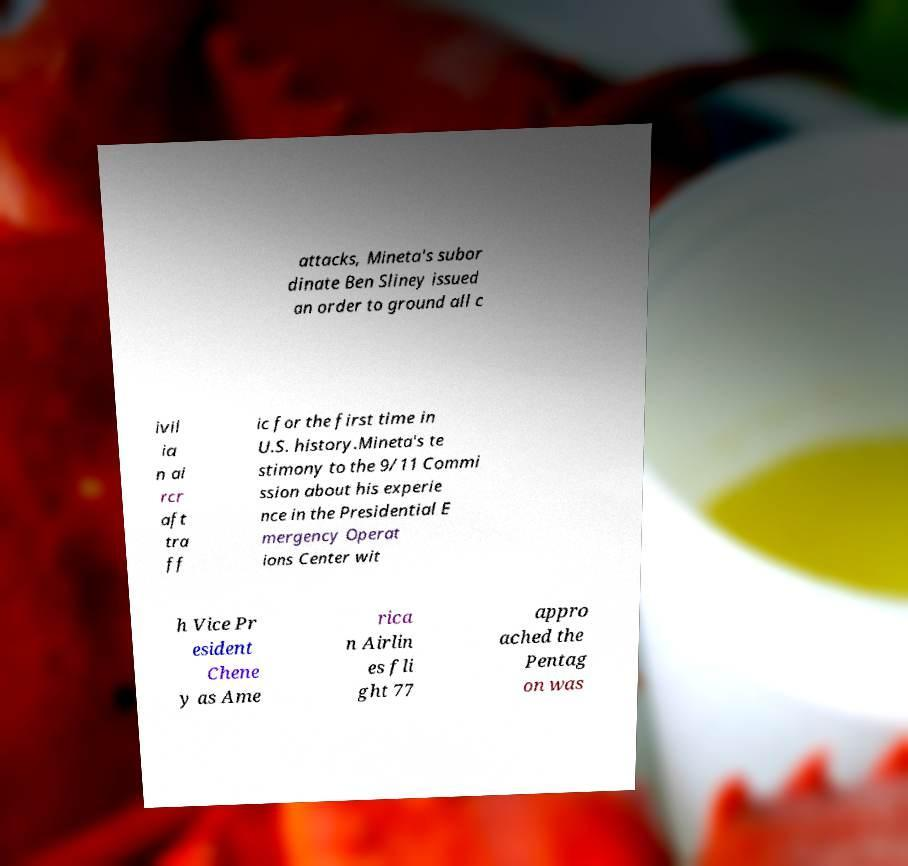Could you assist in decoding the text presented in this image and type it out clearly? attacks, Mineta's subor dinate Ben Sliney issued an order to ground all c ivil ia n ai rcr aft tra ff ic for the first time in U.S. history.Mineta's te stimony to the 9/11 Commi ssion about his experie nce in the Presidential E mergency Operat ions Center wit h Vice Pr esident Chene y as Ame rica n Airlin es fli ght 77 appro ached the Pentag on was 